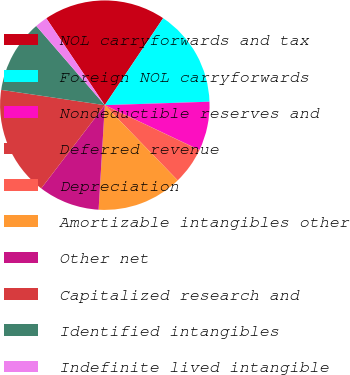<chart> <loc_0><loc_0><loc_500><loc_500><pie_chart><fcel>NOL carryforwards and tax<fcel>Foreign NOL carryforwards<fcel>Nondeductible reserves and<fcel>Deferred revenue<fcel>Depreciation<fcel>Amortizable intangibles other<fcel>Other net<fcel>Capitalized research and<fcel>Identified intangibles<fcel>Indefinite lived intangible<nl><fcel>18.84%<fcel>15.08%<fcel>7.56%<fcel>0.04%<fcel>5.68%<fcel>13.2%<fcel>9.44%<fcel>16.96%<fcel>11.32%<fcel>1.92%<nl></chart> 